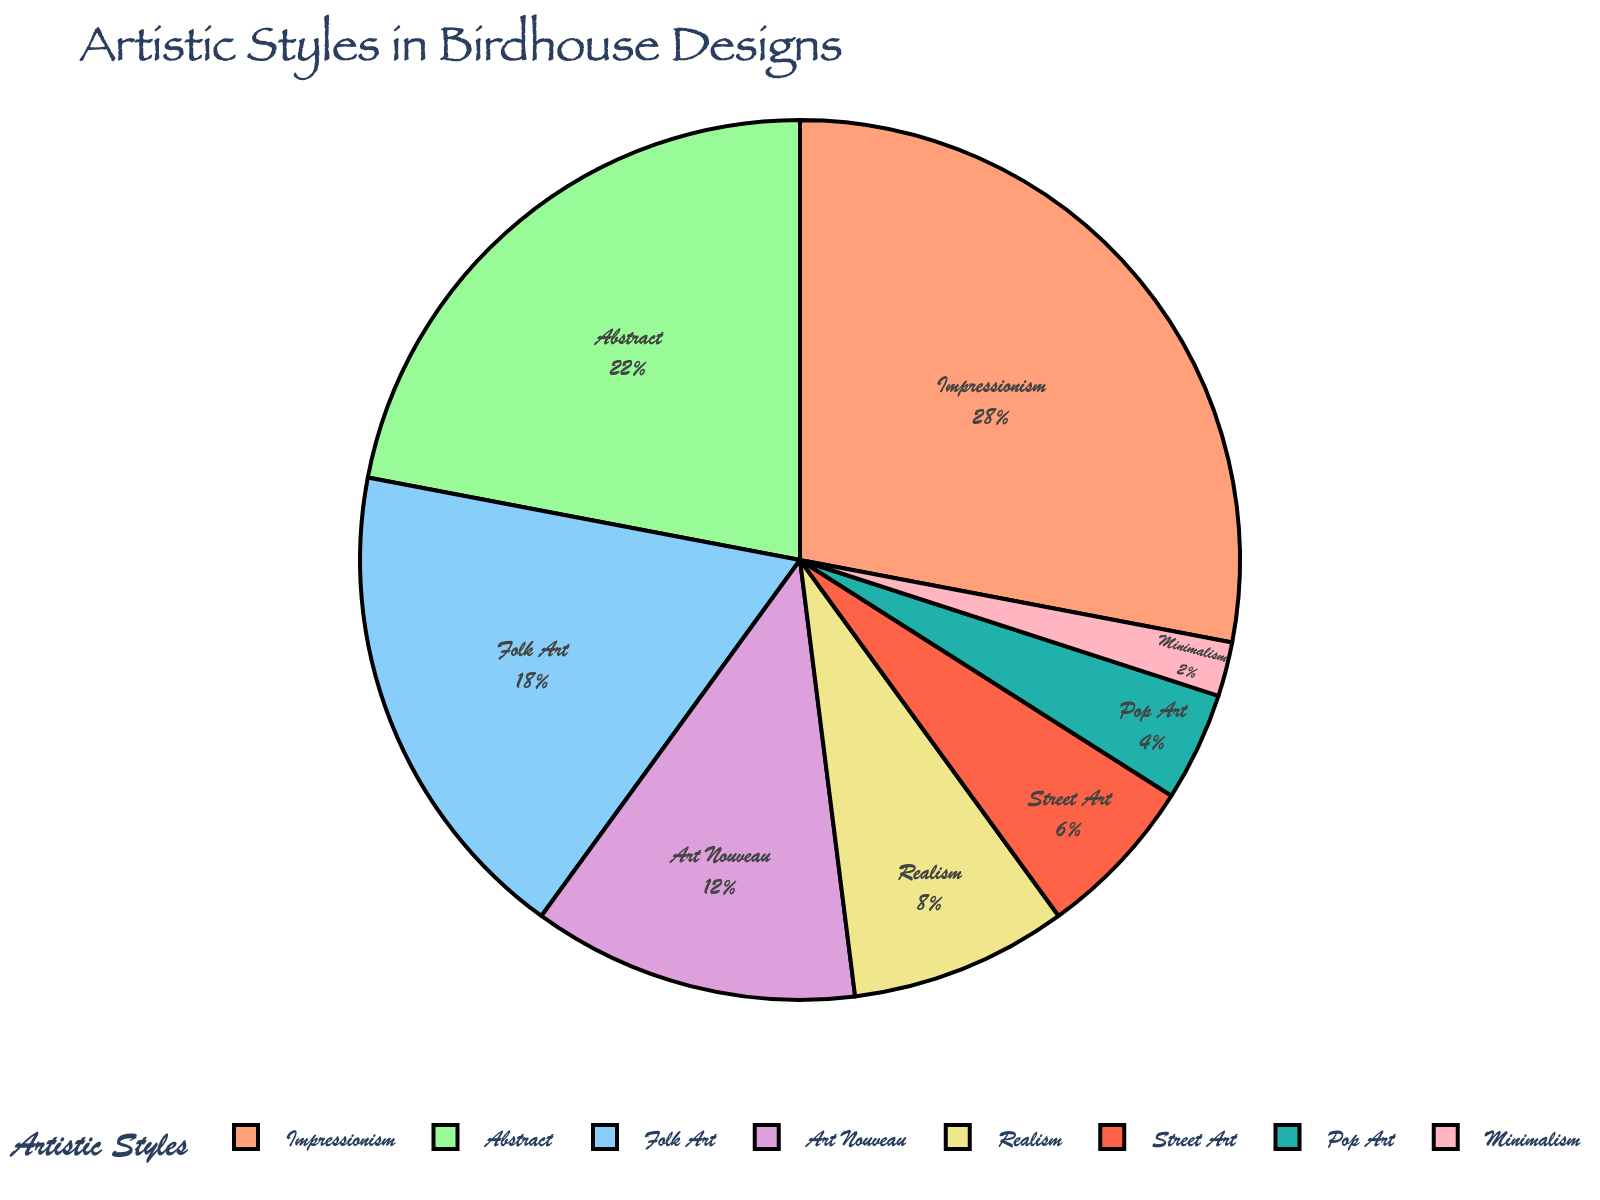What proportion of birdhouse designs incorporate Impressionism compared to Abstract? Impressionism has a 28% share while Abstract accounts for 22%. The difference in their proportions is found by 28% - 22%, which equals 6%.
Answer: 6% Which artistic style is the most prevalent in birdhouse designs? By visually identifying the segment with the largest value, the chart shows that Impressionism comprises 28%, making it the most prevalent style.
Answer: Impressionism How do the proportions of Folk Art and Art Nouveau combined compare to that of Impressionism? Folk Art is at 18% and Art Nouveau at 12%. Combined, they total 18% + 12% = 30%, which is 2% more than Impressionism at 28%.
Answer: 30%, 2% more What is the percentage of designs that do not include Impressionism, Abstract, or Folk Art? To find this, subtract the combined percentage of Impressionism, Abstract, and Folk Art from 100%. That is 100% - (28% + 22% + 18%) = 100% - 68% = 32%.
Answer: 32% Is Minimalism or Pop Art incorporated more in birdhouse designs? Minimalism represents 2% while Pop Art represents 4%, which makes Pop Art included more often than Minimalism.
Answer: Pop Art What percentage of birdhouse designs incorporate either Realism or Street Art? Realism draws 8% and Street Art 6%. Adding these gives 8% + 6% = 14%.
Answer: 14% Rank the artistic styles from most to least used in the birdhouse designs. Observing the chart, the order from most to least used is: Impressionism, Abstract, Folk Art, Art Nouveau, Realism, Street Art, Pop Art, Minimalism.
Answer: Impressionism > Abstract > Folk Art > Art Nouveau > Realism > Street Art > Pop Art > Minimalism Which styles have proportions that are less than 10%? By checking the segments each having less than 10%, we see that Realism (8%), Street Art (6%), Pop Art (4%), and Minimalism (2%) fall under this criterion.
Answer: Realism, Street Art, Pop Art, Minimalism 